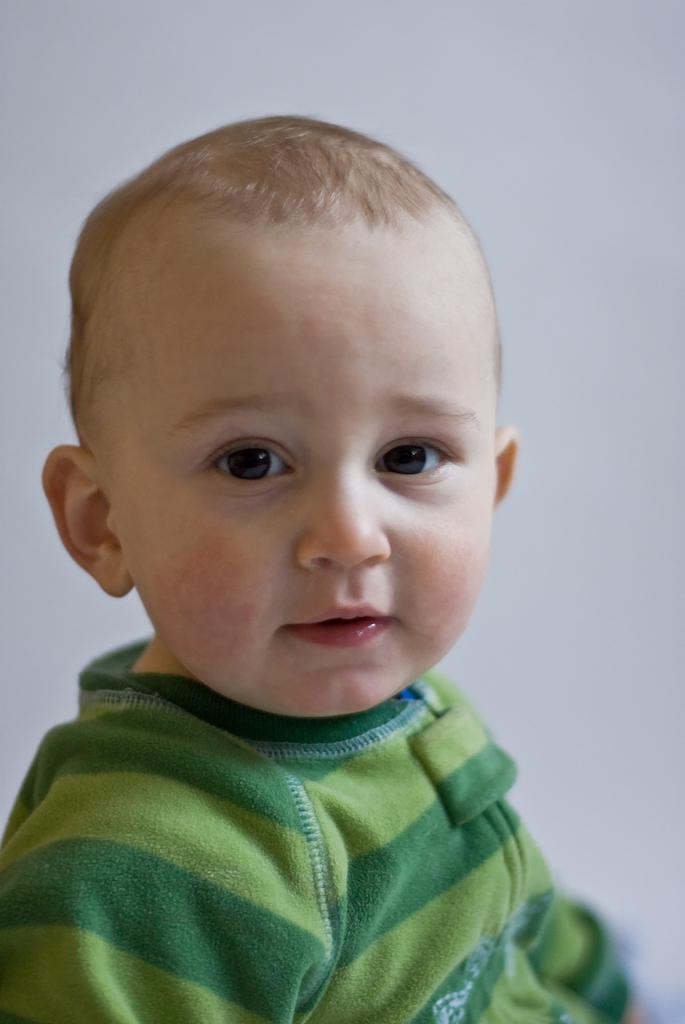What is the main subject of the image? There is a kid in the image. What can be seen in the background of the image? The background of the image is white. How many feathers can be seen on the snakes in the image? There are no snakes or feathers present in the image; it features a kid with a white background. 